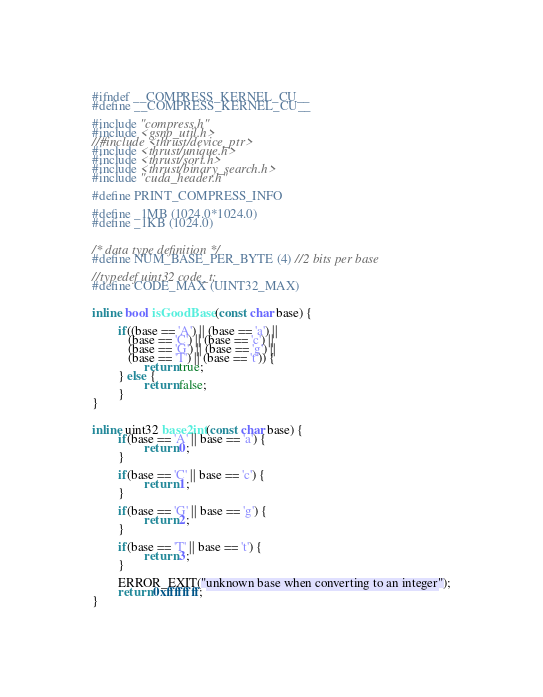<code> <loc_0><loc_0><loc_500><loc_500><_Cuda_>#ifndef __COMPRESS_KERNEL_CU__
#define __COMPRESS_KERNEL_CU__

#include "compress.h"
#include <gsnp_util.h>
//#include <thrust/device_ptr>
#include <thrust/unique.h>
#include <thrust/sort.h>
#include <thrust/binary_search.h>
#include "cuda_header.h"

#define PRINT_COMPRESS_INFO

#define _1MB (1024.0*1024.0)
#define _1KB (1024.0)


/* data type definition */
#define NUM_BASE_PER_BYTE (4) //2 bits per base

//typedef uint32 code_t;
#define CODE_MAX (UINT32_MAX)


inline bool isGoodBase(const char base) {

        if((base == 'A') || (base == 'a') ||
           (base == 'C') || (base == 'c') ||
           (base == 'G') || (base == 'g') ||
           (base == 'T') || (base == 't')) {
                return true;
        } else {
                return false;
        }
}


inline uint32 base2int(const char base) {
        if(base == 'A' || base == 'a') {
                return 0;
        }

        if(base == 'C' || base == 'c') {
                return 1;
        }

        if(base == 'G' || base == 'g') {
                return 2;
        }

        if(base == 'T' || base == 't') {
                return 3;
        }

        ERROR_EXIT("unknown base when converting to an integer");
        return 0xffffffff;
}

</code> 